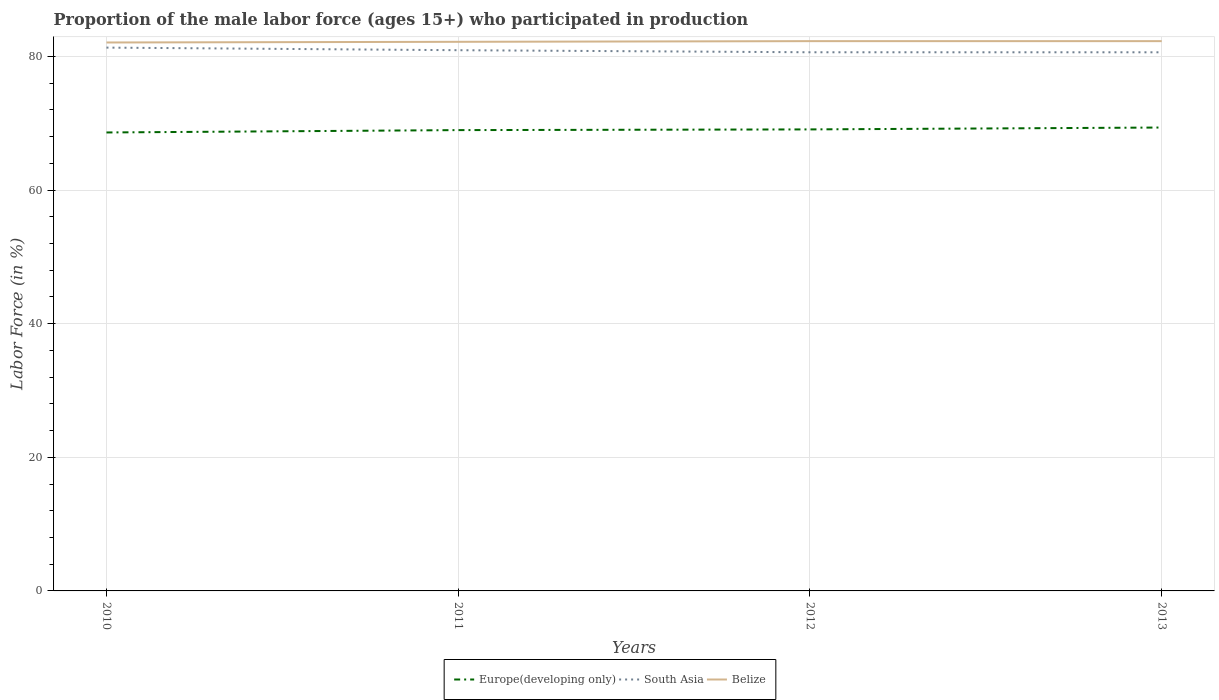How many different coloured lines are there?
Provide a short and direct response. 3. Does the line corresponding to Europe(developing only) intersect with the line corresponding to Belize?
Your response must be concise. No. Is the number of lines equal to the number of legend labels?
Provide a short and direct response. Yes. Across all years, what is the maximum proportion of the male labor force who participated in production in Belize?
Make the answer very short. 82.1. In which year was the proportion of the male labor force who participated in production in South Asia maximum?
Your answer should be compact. 2013. What is the total proportion of the male labor force who participated in production in Belize in the graph?
Offer a terse response. -0.1. What is the difference between the highest and the second highest proportion of the male labor force who participated in production in South Asia?
Make the answer very short. 0.7. What is the difference between the highest and the lowest proportion of the male labor force who participated in production in South Asia?
Give a very brief answer. 2. Is the proportion of the male labor force who participated in production in South Asia strictly greater than the proportion of the male labor force who participated in production in Belize over the years?
Your response must be concise. Yes. What is the difference between two consecutive major ticks on the Y-axis?
Provide a short and direct response. 20. Are the values on the major ticks of Y-axis written in scientific E-notation?
Your response must be concise. No. Does the graph contain any zero values?
Keep it short and to the point. No. Does the graph contain grids?
Make the answer very short. Yes. What is the title of the graph?
Give a very brief answer. Proportion of the male labor force (ages 15+) who participated in production. Does "Yemen, Rep." appear as one of the legend labels in the graph?
Provide a short and direct response. No. What is the label or title of the X-axis?
Give a very brief answer. Years. What is the Labor Force (in %) of Europe(developing only) in 2010?
Keep it short and to the point. 68.63. What is the Labor Force (in %) of South Asia in 2010?
Your response must be concise. 81.33. What is the Labor Force (in %) of Belize in 2010?
Provide a succinct answer. 82.1. What is the Labor Force (in %) of Europe(developing only) in 2011?
Offer a terse response. 68.98. What is the Labor Force (in %) in South Asia in 2011?
Your response must be concise. 80.94. What is the Labor Force (in %) in Belize in 2011?
Keep it short and to the point. 82.2. What is the Labor Force (in %) of Europe(developing only) in 2012?
Your response must be concise. 69.09. What is the Labor Force (in %) in South Asia in 2012?
Your answer should be very brief. 80.64. What is the Labor Force (in %) in Belize in 2012?
Offer a very short reply. 82.3. What is the Labor Force (in %) in Europe(developing only) in 2013?
Offer a very short reply. 69.37. What is the Labor Force (in %) in South Asia in 2013?
Offer a terse response. 80.63. What is the Labor Force (in %) in Belize in 2013?
Give a very brief answer. 82.3. Across all years, what is the maximum Labor Force (in %) in Europe(developing only)?
Keep it short and to the point. 69.37. Across all years, what is the maximum Labor Force (in %) of South Asia?
Your response must be concise. 81.33. Across all years, what is the maximum Labor Force (in %) in Belize?
Ensure brevity in your answer.  82.3. Across all years, what is the minimum Labor Force (in %) in Europe(developing only)?
Provide a succinct answer. 68.63. Across all years, what is the minimum Labor Force (in %) in South Asia?
Give a very brief answer. 80.63. Across all years, what is the minimum Labor Force (in %) in Belize?
Provide a short and direct response. 82.1. What is the total Labor Force (in %) of Europe(developing only) in the graph?
Provide a succinct answer. 276.07. What is the total Labor Force (in %) in South Asia in the graph?
Provide a short and direct response. 323.54. What is the total Labor Force (in %) in Belize in the graph?
Keep it short and to the point. 328.9. What is the difference between the Labor Force (in %) in Europe(developing only) in 2010 and that in 2011?
Your response must be concise. -0.35. What is the difference between the Labor Force (in %) in South Asia in 2010 and that in 2011?
Offer a terse response. 0.39. What is the difference between the Labor Force (in %) of Europe(developing only) in 2010 and that in 2012?
Ensure brevity in your answer.  -0.46. What is the difference between the Labor Force (in %) in South Asia in 2010 and that in 2012?
Ensure brevity in your answer.  0.7. What is the difference between the Labor Force (in %) in Belize in 2010 and that in 2012?
Give a very brief answer. -0.2. What is the difference between the Labor Force (in %) of Europe(developing only) in 2010 and that in 2013?
Ensure brevity in your answer.  -0.74. What is the difference between the Labor Force (in %) in South Asia in 2010 and that in 2013?
Give a very brief answer. 0.7. What is the difference between the Labor Force (in %) of Belize in 2010 and that in 2013?
Keep it short and to the point. -0.2. What is the difference between the Labor Force (in %) of Europe(developing only) in 2011 and that in 2012?
Your answer should be compact. -0.1. What is the difference between the Labor Force (in %) in South Asia in 2011 and that in 2012?
Keep it short and to the point. 0.31. What is the difference between the Labor Force (in %) in Belize in 2011 and that in 2012?
Make the answer very short. -0.1. What is the difference between the Labor Force (in %) in Europe(developing only) in 2011 and that in 2013?
Offer a terse response. -0.39. What is the difference between the Labor Force (in %) in South Asia in 2011 and that in 2013?
Provide a short and direct response. 0.31. What is the difference between the Labor Force (in %) in Belize in 2011 and that in 2013?
Your answer should be very brief. -0.1. What is the difference between the Labor Force (in %) in Europe(developing only) in 2012 and that in 2013?
Offer a very short reply. -0.28. What is the difference between the Labor Force (in %) of South Asia in 2012 and that in 2013?
Your answer should be very brief. 0. What is the difference between the Labor Force (in %) of Europe(developing only) in 2010 and the Labor Force (in %) of South Asia in 2011?
Provide a short and direct response. -12.31. What is the difference between the Labor Force (in %) of Europe(developing only) in 2010 and the Labor Force (in %) of Belize in 2011?
Keep it short and to the point. -13.57. What is the difference between the Labor Force (in %) in South Asia in 2010 and the Labor Force (in %) in Belize in 2011?
Make the answer very short. -0.87. What is the difference between the Labor Force (in %) in Europe(developing only) in 2010 and the Labor Force (in %) in South Asia in 2012?
Offer a very short reply. -12.01. What is the difference between the Labor Force (in %) of Europe(developing only) in 2010 and the Labor Force (in %) of Belize in 2012?
Your answer should be compact. -13.67. What is the difference between the Labor Force (in %) of South Asia in 2010 and the Labor Force (in %) of Belize in 2012?
Provide a short and direct response. -0.97. What is the difference between the Labor Force (in %) of Europe(developing only) in 2010 and the Labor Force (in %) of South Asia in 2013?
Provide a succinct answer. -12. What is the difference between the Labor Force (in %) in Europe(developing only) in 2010 and the Labor Force (in %) in Belize in 2013?
Ensure brevity in your answer.  -13.67. What is the difference between the Labor Force (in %) of South Asia in 2010 and the Labor Force (in %) of Belize in 2013?
Make the answer very short. -0.97. What is the difference between the Labor Force (in %) in Europe(developing only) in 2011 and the Labor Force (in %) in South Asia in 2012?
Make the answer very short. -11.65. What is the difference between the Labor Force (in %) in Europe(developing only) in 2011 and the Labor Force (in %) in Belize in 2012?
Provide a short and direct response. -13.32. What is the difference between the Labor Force (in %) of South Asia in 2011 and the Labor Force (in %) of Belize in 2012?
Give a very brief answer. -1.36. What is the difference between the Labor Force (in %) of Europe(developing only) in 2011 and the Labor Force (in %) of South Asia in 2013?
Keep it short and to the point. -11.65. What is the difference between the Labor Force (in %) of Europe(developing only) in 2011 and the Labor Force (in %) of Belize in 2013?
Make the answer very short. -13.32. What is the difference between the Labor Force (in %) in South Asia in 2011 and the Labor Force (in %) in Belize in 2013?
Offer a very short reply. -1.36. What is the difference between the Labor Force (in %) of Europe(developing only) in 2012 and the Labor Force (in %) of South Asia in 2013?
Keep it short and to the point. -11.54. What is the difference between the Labor Force (in %) in Europe(developing only) in 2012 and the Labor Force (in %) in Belize in 2013?
Keep it short and to the point. -13.21. What is the difference between the Labor Force (in %) of South Asia in 2012 and the Labor Force (in %) of Belize in 2013?
Make the answer very short. -1.67. What is the average Labor Force (in %) of Europe(developing only) per year?
Your answer should be very brief. 69.02. What is the average Labor Force (in %) of South Asia per year?
Your answer should be very brief. 80.89. What is the average Labor Force (in %) in Belize per year?
Your response must be concise. 82.22. In the year 2010, what is the difference between the Labor Force (in %) in Europe(developing only) and Labor Force (in %) in South Asia?
Ensure brevity in your answer.  -12.7. In the year 2010, what is the difference between the Labor Force (in %) in Europe(developing only) and Labor Force (in %) in Belize?
Give a very brief answer. -13.47. In the year 2010, what is the difference between the Labor Force (in %) in South Asia and Labor Force (in %) in Belize?
Ensure brevity in your answer.  -0.77. In the year 2011, what is the difference between the Labor Force (in %) of Europe(developing only) and Labor Force (in %) of South Asia?
Keep it short and to the point. -11.96. In the year 2011, what is the difference between the Labor Force (in %) in Europe(developing only) and Labor Force (in %) in Belize?
Give a very brief answer. -13.22. In the year 2011, what is the difference between the Labor Force (in %) in South Asia and Labor Force (in %) in Belize?
Your answer should be compact. -1.26. In the year 2012, what is the difference between the Labor Force (in %) of Europe(developing only) and Labor Force (in %) of South Asia?
Make the answer very short. -11.55. In the year 2012, what is the difference between the Labor Force (in %) in Europe(developing only) and Labor Force (in %) in Belize?
Offer a terse response. -13.21. In the year 2012, what is the difference between the Labor Force (in %) in South Asia and Labor Force (in %) in Belize?
Provide a short and direct response. -1.67. In the year 2013, what is the difference between the Labor Force (in %) of Europe(developing only) and Labor Force (in %) of South Asia?
Your answer should be compact. -11.26. In the year 2013, what is the difference between the Labor Force (in %) of Europe(developing only) and Labor Force (in %) of Belize?
Provide a succinct answer. -12.93. In the year 2013, what is the difference between the Labor Force (in %) in South Asia and Labor Force (in %) in Belize?
Offer a very short reply. -1.67. What is the ratio of the Labor Force (in %) in Europe(developing only) in 2010 to that in 2011?
Your answer should be very brief. 0.99. What is the ratio of the Labor Force (in %) of South Asia in 2010 to that in 2011?
Give a very brief answer. 1. What is the ratio of the Labor Force (in %) in Belize in 2010 to that in 2011?
Provide a short and direct response. 1. What is the ratio of the Labor Force (in %) of Europe(developing only) in 2010 to that in 2012?
Your answer should be very brief. 0.99. What is the ratio of the Labor Force (in %) of South Asia in 2010 to that in 2012?
Offer a terse response. 1.01. What is the ratio of the Labor Force (in %) of Europe(developing only) in 2010 to that in 2013?
Ensure brevity in your answer.  0.99. What is the ratio of the Labor Force (in %) of South Asia in 2010 to that in 2013?
Give a very brief answer. 1.01. What is the ratio of the Labor Force (in %) in South Asia in 2011 to that in 2012?
Make the answer very short. 1. What is the ratio of the Labor Force (in %) in Belize in 2011 to that in 2012?
Your response must be concise. 1. What is the ratio of the Labor Force (in %) of Europe(developing only) in 2011 to that in 2013?
Keep it short and to the point. 0.99. What is the ratio of the Labor Force (in %) of Europe(developing only) in 2012 to that in 2013?
Provide a succinct answer. 1. What is the difference between the highest and the second highest Labor Force (in %) of Europe(developing only)?
Offer a very short reply. 0.28. What is the difference between the highest and the second highest Labor Force (in %) in South Asia?
Offer a very short reply. 0.39. What is the difference between the highest and the second highest Labor Force (in %) of Belize?
Your response must be concise. 0. What is the difference between the highest and the lowest Labor Force (in %) of Europe(developing only)?
Ensure brevity in your answer.  0.74. What is the difference between the highest and the lowest Labor Force (in %) of South Asia?
Your answer should be compact. 0.7. What is the difference between the highest and the lowest Labor Force (in %) of Belize?
Offer a terse response. 0.2. 